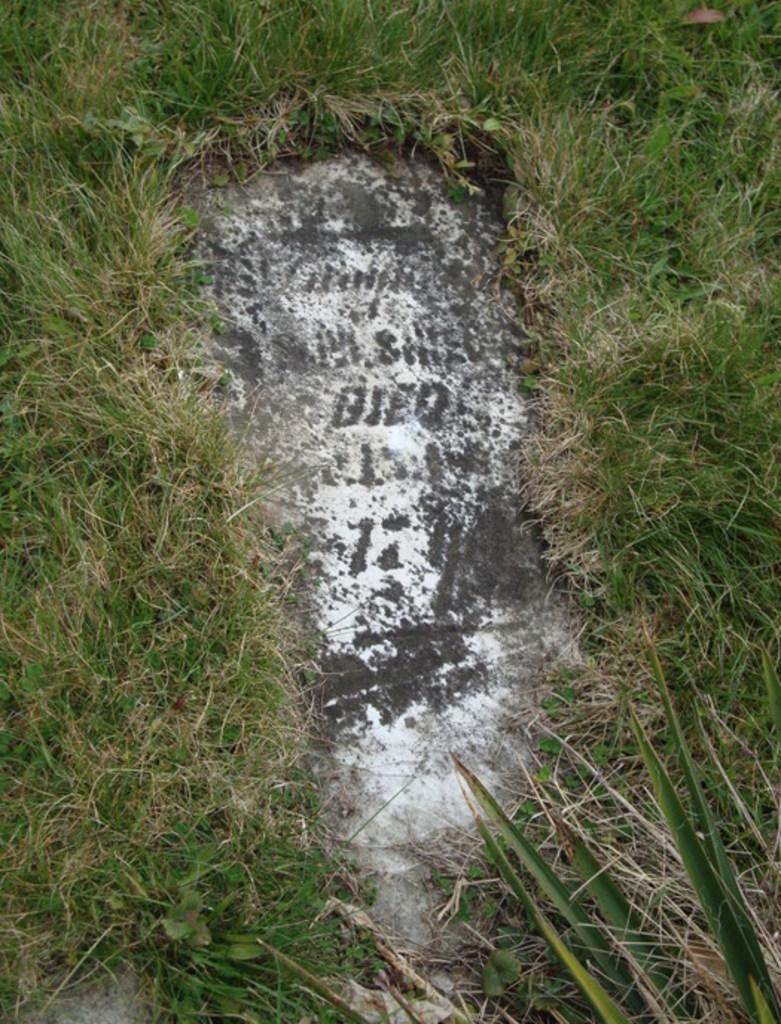Could you give a brief overview of what you see in this image? In this image we can see a tomb around the grass. 